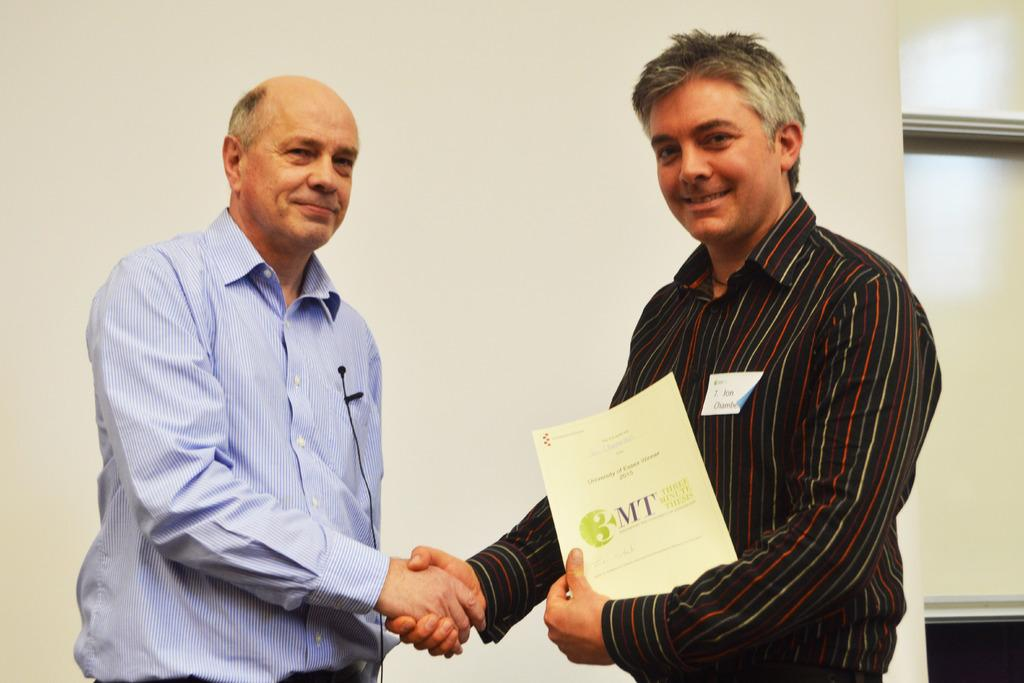How many men are in the foreground of the image? There are two men in the foreground of the image. What are the two men doing in the image? The two men are shaking hands in the image. Is there anyone else holding a paper in the foreground? Yes, there is a man holding a paper in the foreground. What can be seen in the background of the image? There is a wall in the background of the image. Can you see a volcano erupting in the background of the image? No, there is no volcano present in the image. Are there any children playing on a playground in the image? No, there is no playground or children visible in the image. 